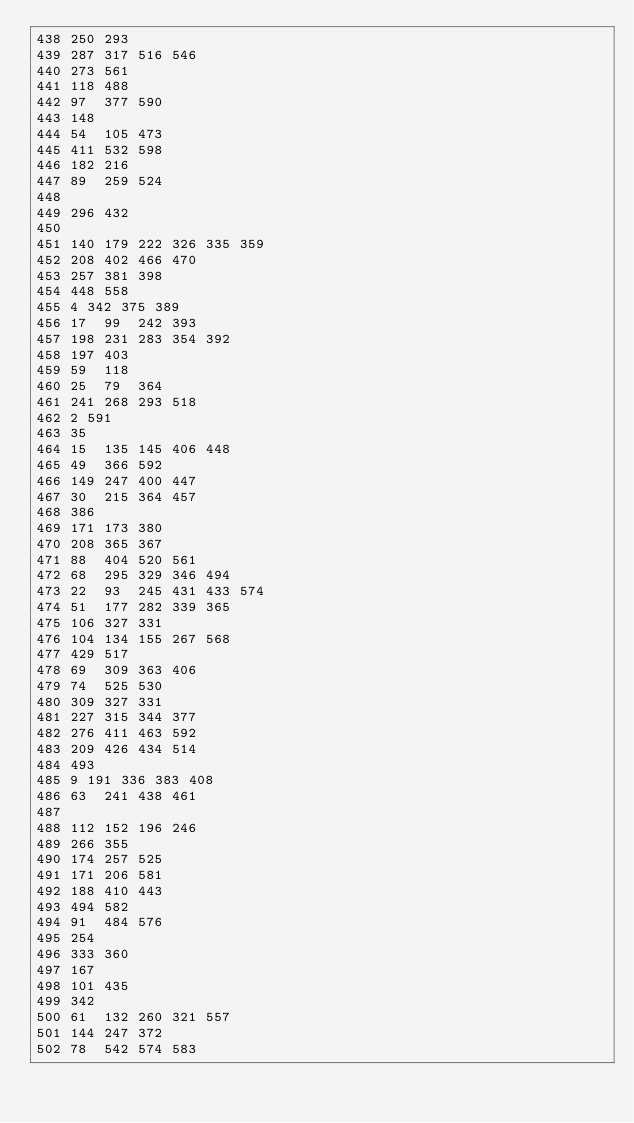Convert code to text. <code><loc_0><loc_0><loc_500><loc_500><_Perl_>438	250	293
439	287	317	516	546
440	273	561
441	118	488
442	97	377	590
443	148
444	54	105	473
445	411	532	598
446	182	216
447	89	259	524
448
449	296	432
450
451	140	179	222	326	335	359
452	208	402	466	470
453	257	381	398
454	448	558
455	4	342	375	389
456	17	99	242	393
457	198	231	283	354	392
458	197	403
459	59	118
460	25	79	364
461	241	268	293	518
462	2	591
463	35
464	15	135	145	406	448
465	49	366	592
466	149	247	400	447
467	30	215	364	457
468	386
469	171	173	380
470	208	365	367
471	88	404	520	561
472	68	295	329	346	494
473	22	93	245	431	433	574
474	51	177	282	339	365
475	106	327	331
476	104	134	155	267	568
477	429	517
478	69	309	363	406
479	74	525	530
480	309	327	331
481	227	315	344	377
482	276	411	463	592
483	209	426	434	514
484	493
485	9	191	336	383	408
486	63	241	438	461
487
488	112	152	196	246
489	266	355
490	174	257	525
491	171	206	581
492	188	410	443
493	494	582
494	91	484	576
495	254
496	333	360
497	167
498	101	435
499	342
500	61	132	260	321	557
501	144	247	372
502	78	542	574	583</code> 